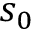<formula> <loc_0><loc_0><loc_500><loc_500>s _ { 0 }</formula> 